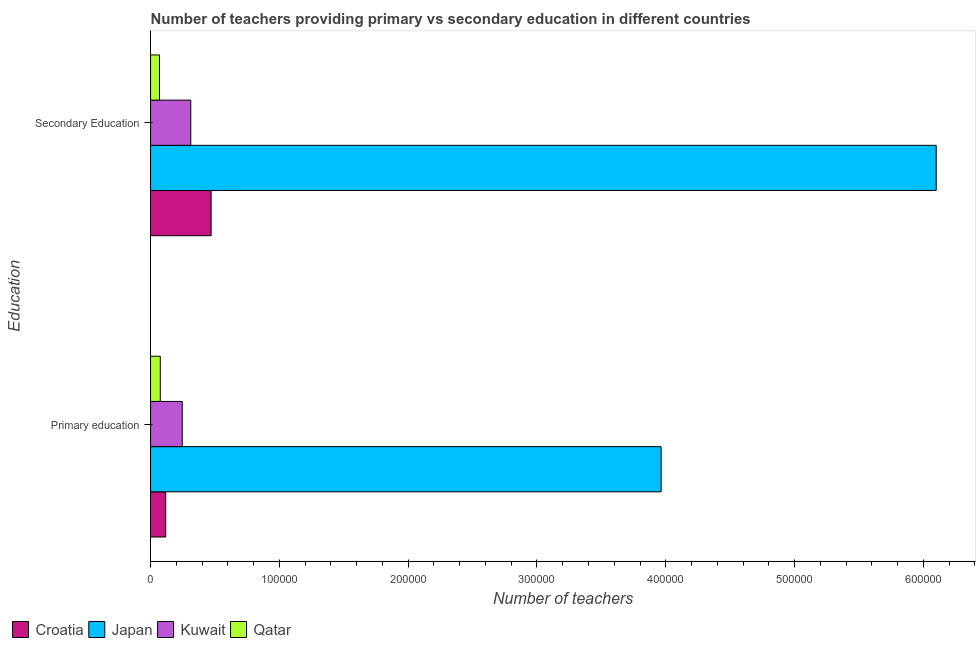How many groups of bars are there?
Keep it short and to the point. 2. Are the number of bars on each tick of the Y-axis equal?
Provide a succinct answer. Yes. What is the label of the 2nd group of bars from the top?
Give a very brief answer. Primary education. What is the number of secondary teachers in Qatar?
Offer a terse response. 6923. Across all countries, what is the maximum number of primary teachers?
Make the answer very short. 3.96e+05. Across all countries, what is the minimum number of secondary teachers?
Offer a terse response. 6923. In which country was the number of primary teachers maximum?
Keep it short and to the point. Japan. In which country was the number of secondary teachers minimum?
Your answer should be compact. Qatar. What is the total number of primary teachers in the graph?
Provide a short and direct response. 4.40e+05. What is the difference between the number of primary teachers in Croatia and that in Qatar?
Your answer should be compact. 4238. What is the difference between the number of primary teachers in Qatar and the number of secondary teachers in Croatia?
Provide a succinct answer. -3.95e+04. What is the average number of primary teachers per country?
Make the answer very short. 1.10e+05. What is the difference between the number of secondary teachers and number of primary teachers in Qatar?
Offer a terse response. -621. In how many countries, is the number of secondary teachers greater than 160000 ?
Ensure brevity in your answer.  1. What is the ratio of the number of primary teachers in Kuwait to that in Qatar?
Provide a succinct answer. 3.26. Is the number of primary teachers in Qatar less than that in Kuwait?
Ensure brevity in your answer.  Yes. In how many countries, is the number of primary teachers greater than the average number of primary teachers taken over all countries?
Provide a short and direct response. 1. What does the 2nd bar from the top in Secondary Education represents?
Give a very brief answer. Kuwait. What does the 3rd bar from the bottom in Secondary Education represents?
Provide a succinct answer. Kuwait. What is the difference between two consecutive major ticks on the X-axis?
Your response must be concise. 1.00e+05. Does the graph contain grids?
Your response must be concise. No. What is the title of the graph?
Your answer should be compact. Number of teachers providing primary vs secondary education in different countries. What is the label or title of the X-axis?
Your answer should be very brief. Number of teachers. What is the label or title of the Y-axis?
Give a very brief answer. Education. What is the Number of teachers in Croatia in Primary education?
Your answer should be compact. 1.18e+04. What is the Number of teachers in Japan in Primary education?
Ensure brevity in your answer.  3.96e+05. What is the Number of teachers of Kuwait in Primary education?
Ensure brevity in your answer.  2.46e+04. What is the Number of teachers in Qatar in Primary education?
Your response must be concise. 7544. What is the Number of teachers in Croatia in Secondary Education?
Ensure brevity in your answer.  4.70e+04. What is the Number of teachers in Japan in Secondary Education?
Ensure brevity in your answer.  6.10e+05. What is the Number of teachers in Kuwait in Secondary Education?
Your answer should be very brief. 3.12e+04. What is the Number of teachers in Qatar in Secondary Education?
Offer a terse response. 6923. Across all Education, what is the maximum Number of teachers of Croatia?
Your response must be concise. 4.70e+04. Across all Education, what is the maximum Number of teachers of Japan?
Provide a short and direct response. 6.10e+05. Across all Education, what is the maximum Number of teachers in Kuwait?
Give a very brief answer. 3.12e+04. Across all Education, what is the maximum Number of teachers of Qatar?
Your answer should be compact. 7544. Across all Education, what is the minimum Number of teachers of Croatia?
Offer a terse response. 1.18e+04. Across all Education, what is the minimum Number of teachers in Japan?
Your answer should be very brief. 3.96e+05. Across all Education, what is the minimum Number of teachers in Kuwait?
Provide a succinct answer. 2.46e+04. Across all Education, what is the minimum Number of teachers in Qatar?
Offer a terse response. 6923. What is the total Number of teachers of Croatia in the graph?
Keep it short and to the point. 5.88e+04. What is the total Number of teachers of Japan in the graph?
Provide a succinct answer. 1.01e+06. What is the total Number of teachers in Kuwait in the graph?
Your answer should be very brief. 5.58e+04. What is the total Number of teachers in Qatar in the graph?
Offer a terse response. 1.45e+04. What is the difference between the Number of teachers in Croatia in Primary education and that in Secondary Education?
Your answer should be very brief. -3.52e+04. What is the difference between the Number of teachers in Japan in Primary education and that in Secondary Education?
Provide a short and direct response. -2.14e+05. What is the difference between the Number of teachers in Kuwait in Primary education and that in Secondary Education?
Provide a short and direct response. -6601. What is the difference between the Number of teachers of Qatar in Primary education and that in Secondary Education?
Your response must be concise. 621. What is the difference between the Number of teachers in Croatia in Primary education and the Number of teachers in Japan in Secondary Education?
Make the answer very short. -5.98e+05. What is the difference between the Number of teachers of Croatia in Primary education and the Number of teachers of Kuwait in Secondary Education?
Ensure brevity in your answer.  -1.94e+04. What is the difference between the Number of teachers of Croatia in Primary education and the Number of teachers of Qatar in Secondary Education?
Give a very brief answer. 4859. What is the difference between the Number of teachers in Japan in Primary education and the Number of teachers in Kuwait in Secondary Education?
Make the answer very short. 3.65e+05. What is the difference between the Number of teachers in Japan in Primary education and the Number of teachers in Qatar in Secondary Education?
Ensure brevity in your answer.  3.89e+05. What is the difference between the Number of teachers in Kuwait in Primary education and the Number of teachers in Qatar in Secondary Education?
Ensure brevity in your answer.  1.77e+04. What is the average Number of teachers of Croatia per Education?
Provide a short and direct response. 2.94e+04. What is the average Number of teachers of Japan per Education?
Make the answer very short. 5.03e+05. What is the average Number of teachers in Kuwait per Education?
Offer a terse response. 2.79e+04. What is the average Number of teachers in Qatar per Education?
Offer a terse response. 7233.5. What is the difference between the Number of teachers in Croatia and Number of teachers in Japan in Primary education?
Provide a succinct answer. -3.85e+05. What is the difference between the Number of teachers of Croatia and Number of teachers of Kuwait in Primary education?
Give a very brief answer. -1.28e+04. What is the difference between the Number of teachers of Croatia and Number of teachers of Qatar in Primary education?
Your answer should be compact. 4238. What is the difference between the Number of teachers of Japan and Number of teachers of Kuwait in Primary education?
Provide a short and direct response. 3.72e+05. What is the difference between the Number of teachers of Japan and Number of teachers of Qatar in Primary education?
Offer a terse response. 3.89e+05. What is the difference between the Number of teachers of Kuwait and Number of teachers of Qatar in Primary education?
Keep it short and to the point. 1.71e+04. What is the difference between the Number of teachers in Croatia and Number of teachers in Japan in Secondary Education?
Provide a short and direct response. -5.63e+05. What is the difference between the Number of teachers in Croatia and Number of teachers in Kuwait in Secondary Education?
Offer a very short reply. 1.58e+04. What is the difference between the Number of teachers in Croatia and Number of teachers in Qatar in Secondary Education?
Provide a short and direct response. 4.01e+04. What is the difference between the Number of teachers in Japan and Number of teachers in Kuwait in Secondary Education?
Provide a succinct answer. 5.79e+05. What is the difference between the Number of teachers in Japan and Number of teachers in Qatar in Secondary Education?
Keep it short and to the point. 6.03e+05. What is the difference between the Number of teachers in Kuwait and Number of teachers in Qatar in Secondary Education?
Provide a short and direct response. 2.43e+04. What is the ratio of the Number of teachers in Croatia in Primary education to that in Secondary Education?
Make the answer very short. 0.25. What is the ratio of the Number of teachers of Japan in Primary education to that in Secondary Education?
Make the answer very short. 0.65. What is the ratio of the Number of teachers of Kuwait in Primary education to that in Secondary Education?
Make the answer very short. 0.79. What is the ratio of the Number of teachers in Qatar in Primary education to that in Secondary Education?
Provide a succinct answer. 1.09. What is the difference between the highest and the second highest Number of teachers of Croatia?
Offer a terse response. 3.52e+04. What is the difference between the highest and the second highest Number of teachers of Japan?
Give a very brief answer. 2.14e+05. What is the difference between the highest and the second highest Number of teachers of Kuwait?
Your answer should be very brief. 6601. What is the difference between the highest and the second highest Number of teachers in Qatar?
Provide a short and direct response. 621. What is the difference between the highest and the lowest Number of teachers of Croatia?
Provide a short and direct response. 3.52e+04. What is the difference between the highest and the lowest Number of teachers of Japan?
Provide a short and direct response. 2.14e+05. What is the difference between the highest and the lowest Number of teachers in Kuwait?
Provide a succinct answer. 6601. What is the difference between the highest and the lowest Number of teachers in Qatar?
Provide a succinct answer. 621. 